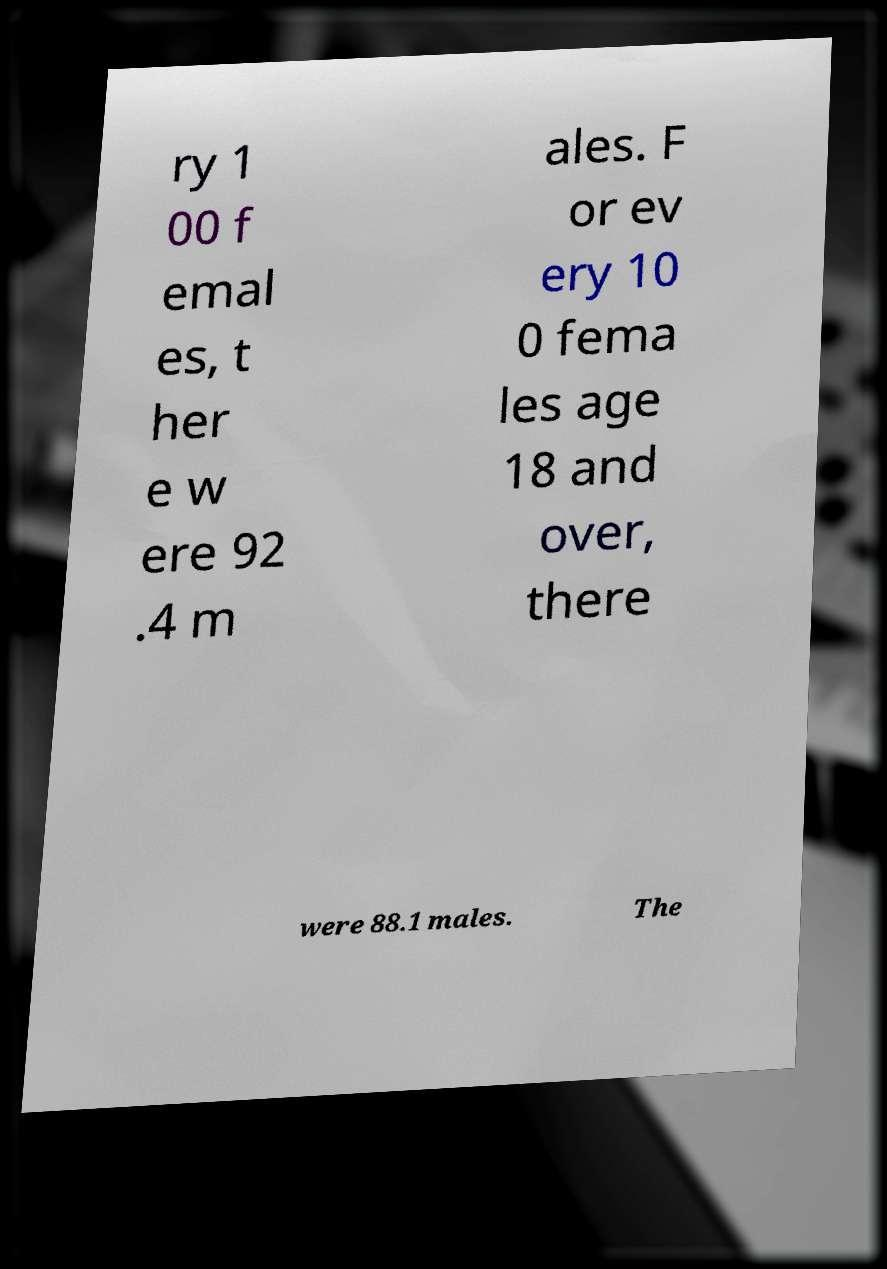Please identify and transcribe the text found in this image. ry 1 00 f emal es, t her e w ere 92 .4 m ales. F or ev ery 10 0 fema les age 18 and over, there were 88.1 males. The 